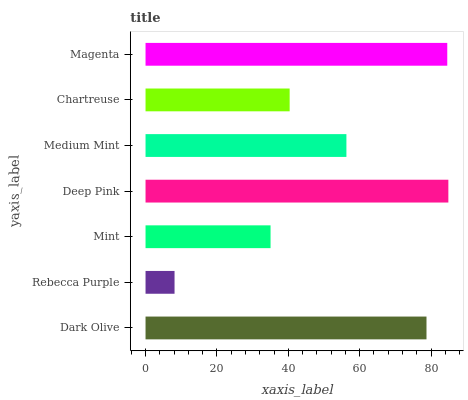Is Rebecca Purple the minimum?
Answer yes or no. Yes. Is Deep Pink the maximum?
Answer yes or no. Yes. Is Mint the minimum?
Answer yes or no. No. Is Mint the maximum?
Answer yes or no. No. Is Mint greater than Rebecca Purple?
Answer yes or no. Yes. Is Rebecca Purple less than Mint?
Answer yes or no. Yes. Is Rebecca Purple greater than Mint?
Answer yes or no. No. Is Mint less than Rebecca Purple?
Answer yes or no. No. Is Medium Mint the high median?
Answer yes or no. Yes. Is Medium Mint the low median?
Answer yes or no. Yes. Is Dark Olive the high median?
Answer yes or no. No. Is Deep Pink the low median?
Answer yes or no. No. 